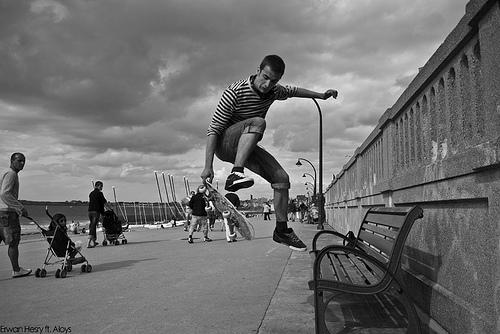Is the boy touching the skateboard?
Write a very short answer. Yes. Is the color purple anywhere in the picture?
Quick response, please. No. How many strollers are there?
Give a very brief answer. 2. What is the man jumping on?
Short answer required. Skateboard. 